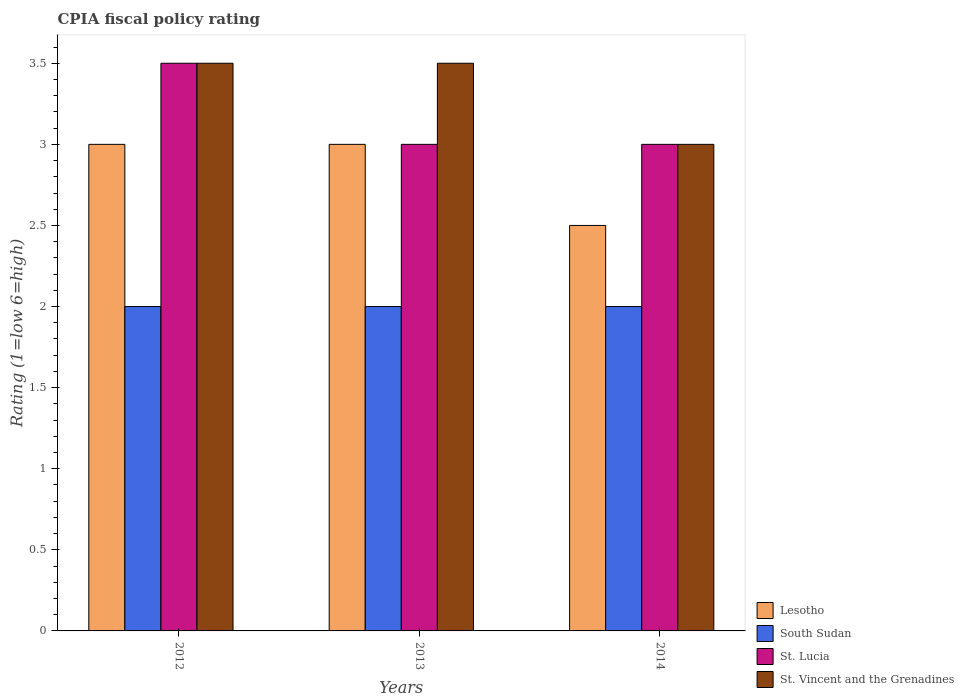Are the number of bars on each tick of the X-axis equal?
Your response must be concise. Yes. How many bars are there on the 2nd tick from the left?
Provide a short and direct response. 4. How many bars are there on the 3rd tick from the right?
Ensure brevity in your answer.  4. What is the label of the 1st group of bars from the left?
Offer a very short reply. 2012. What is the CPIA rating in St. Vincent and the Grenadines in 2013?
Provide a short and direct response. 3.5. Across all years, what is the maximum CPIA rating in South Sudan?
Offer a terse response. 2. In which year was the CPIA rating in Lesotho maximum?
Provide a succinct answer. 2012. In which year was the CPIA rating in St. Lucia minimum?
Provide a short and direct response. 2013. What is the total CPIA rating in Lesotho in the graph?
Give a very brief answer. 8.5. What is the difference between the CPIA rating in St. Lucia in 2013 and that in 2014?
Offer a terse response. 0. What is the average CPIA rating in St. Vincent and the Grenadines per year?
Provide a succinct answer. 3.33. What is the ratio of the CPIA rating in St. Lucia in 2012 to that in 2014?
Your answer should be compact. 1.17. Is the difference between the CPIA rating in St. Vincent and the Grenadines in 2012 and 2013 greater than the difference between the CPIA rating in South Sudan in 2012 and 2013?
Ensure brevity in your answer.  No. What is the difference between the highest and the second highest CPIA rating in St. Lucia?
Provide a short and direct response. 0.5. What is the difference between the highest and the lowest CPIA rating in St. Lucia?
Make the answer very short. 0.5. In how many years, is the CPIA rating in Lesotho greater than the average CPIA rating in Lesotho taken over all years?
Keep it short and to the point. 2. What does the 3rd bar from the left in 2013 represents?
Make the answer very short. St. Lucia. What does the 2nd bar from the right in 2014 represents?
Provide a succinct answer. St. Lucia. Is it the case that in every year, the sum of the CPIA rating in Lesotho and CPIA rating in South Sudan is greater than the CPIA rating in St. Lucia?
Your response must be concise. Yes. How many bars are there?
Ensure brevity in your answer.  12. How many years are there in the graph?
Your answer should be very brief. 3. Does the graph contain grids?
Ensure brevity in your answer.  No. Where does the legend appear in the graph?
Your response must be concise. Bottom right. How many legend labels are there?
Keep it short and to the point. 4. How are the legend labels stacked?
Provide a short and direct response. Vertical. What is the title of the graph?
Offer a terse response. CPIA fiscal policy rating. Does "Heavily indebted poor countries" appear as one of the legend labels in the graph?
Make the answer very short. No. What is the label or title of the X-axis?
Provide a succinct answer. Years. What is the Rating (1=low 6=high) of St. Lucia in 2012?
Ensure brevity in your answer.  3.5. What is the Rating (1=low 6=high) of St. Vincent and the Grenadines in 2012?
Offer a very short reply. 3.5. What is the Rating (1=low 6=high) in Lesotho in 2013?
Provide a succinct answer. 3. What is the Rating (1=low 6=high) of Lesotho in 2014?
Keep it short and to the point. 2.5. What is the Rating (1=low 6=high) of St. Vincent and the Grenadines in 2014?
Ensure brevity in your answer.  3. Across all years, what is the maximum Rating (1=low 6=high) in South Sudan?
Ensure brevity in your answer.  2. Across all years, what is the maximum Rating (1=low 6=high) in St. Lucia?
Provide a short and direct response. 3.5. Across all years, what is the maximum Rating (1=low 6=high) of St. Vincent and the Grenadines?
Your answer should be compact. 3.5. Across all years, what is the minimum Rating (1=low 6=high) of South Sudan?
Your response must be concise. 2. Across all years, what is the minimum Rating (1=low 6=high) in St. Vincent and the Grenadines?
Ensure brevity in your answer.  3. What is the total Rating (1=low 6=high) of South Sudan in the graph?
Offer a terse response. 6. What is the difference between the Rating (1=low 6=high) of Lesotho in 2012 and that in 2013?
Offer a very short reply. 0. What is the difference between the Rating (1=low 6=high) of Lesotho in 2012 and that in 2014?
Your answer should be compact. 0.5. What is the difference between the Rating (1=low 6=high) of South Sudan in 2012 and that in 2014?
Give a very brief answer. 0. What is the difference between the Rating (1=low 6=high) in St. Lucia in 2013 and that in 2014?
Offer a very short reply. 0. What is the difference between the Rating (1=low 6=high) in Lesotho in 2012 and the Rating (1=low 6=high) in South Sudan in 2013?
Keep it short and to the point. 1. What is the difference between the Rating (1=low 6=high) in South Sudan in 2012 and the Rating (1=low 6=high) in St. Vincent and the Grenadines in 2013?
Your response must be concise. -1.5. What is the difference between the Rating (1=low 6=high) in Lesotho in 2012 and the Rating (1=low 6=high) in South Sudan in 2014?
Offer a very short reply. 1. What is the difference between the Rating (1=low 6=high) of Lesotho in 2012 and the Rating (1=low 6=high) of St. Vincent and the Grenadines in 2014?
Your response must be concise. 0. What is the difference between the Rating (1=low 6=high) of South Sudan in 2012 and the Rating (1=low 6=high) of St. Vincent and the Grenadines in 2014?
Offer a very short reply. -1. What is the difference between the Rating (1=low 6=high) of Lesotho in 2013 and the Rating (1=low 6=high) of South Sudan in 2014?
Make the answer very short. 1. What is the difference between the Rating (1=low 6=high) of Lesotho in 2013 and the Rating (1=low 6=high) of St. Lucia in 2014?
Offer a terse response. 0. What is the difference between the Rating (1=low 6=high) in South Sudan in 2013 and the Rating (1=low 6=high) in St. Lucia in 2014?
Give a very brief answer. -1. What is the difference between the Rating (1=low 6=high) in South Sudan in 2013 and the Rating (1=low 6=high) in St. Vincent and the Grenadines in 2014?
Ensure brevity in your answer.  -1. What is the average Rating (1=low 6=high) of Lesotho per year?
Your answer should be compact. 2.83. What is the average Rating (1=low 6=high) of South Sudan per year?
Offer a terse response. 2. What is the average Rating (1=low 6=high) in St. Lucia per year?
Provide a short and direct response. 3.17. In the year 2012, what is the difference between the Rating (1=low 6=high) in South Sudan and Rating (1=low 6=high) in St. Lucia?
Your answer should be very brief. -1.5. In the year 2012, what is the difference between the Rating (1=low 6=high) in South Sudan and Rating (1=low 6=high) in St. Vincent and the Grenadines?
Give a very brief answer. -1.5. In the year 2013, what is the difference between the Rating (1=low 6=high) in Lesotho and Rating (1=low 6=high) in St. Lucia?
Keep it short and to the point. 0. In the year 2013, what is the difference between the Rating (1=low 6=high) in Lesotho and Rating (1=low 6=high) in St. Vincent and the Grenadines?
Make the answer very short. -0.5. In the year 2013, what is the difference between the Rating (1=low 6=high) in South Sudan and Rating (1=low 6=high) in St. Vincent and the Grenadines?
Provide a succinct answer. -1.5. In the year 2014, what is the difference between the Rating (1=low 6=high) of Lesotho and Rating (1=low 6=high) of South Sudan?
Give a very brief answer. 0.5. In the year 2014, what is the difference between the Rating (1=low 6=high) in Lesotho and Rating (1=low 6=high) in St. Lucia?
Ensure brevity in your answer.  -0.5. In the year 2014, what is the difference between the Rating (1=low 6=high) in Lesotho and Rating (1=low 6=high) in St. Vincent and the Grenadines?
Offer a very short reply. -0.5. In the year 2014, what is the difference between the Rating (1=low 6=high) in South Sudan and Rating (1=low 6=high) in St. Vincent and the Grenadines?
Offer a very short reply. -1. What is the ratio of the Rating (1=low 6=high) in Lesotho in 2012 to that in 2013?
Offer a very short reply. 1. What is the ratio of the Rating (1=low 6=high) of St. Lucia in 2012 to that in 2013?
Ensure brevity in your answer.  1.17. What is the ratio of the Rating (1=low 6=high) in Lesotho in 2012 to that in 2014?
Offer a very short reply. 1.2. What is the ratio of the Rating (1=low 6=high) in St. Lucia in 2012 to that in 2014?
Offer a very short reply. 1.17. What is the ratio of the Rating (1=low 6=high) in Lesotho in 2013 to that in 2014?
Provide a short and direct response. 1.2. What is the ratio of the Rating (1=low 6=high) in South Sudan in 2013 to that in 2014?
Your answer should be very brief. 1. What is the ratio of the Rating (1=low 6=high) in St. Vincent and the Grenadines in 2013 to that in 2014?
Your response must be concise. 1.17. What is the difference between the highest and the second highest Rating (1=low 6=high) in Lesotho?
Your answer should be compact. 0. What is the difference between the highest and the lowest Rating (1=low 6=high) of Lesotho?
Provide a short and direct response. 0.5. What is the difference between the highest and the lowest Rating (1=low 6=high) of South Sudan?
Provide a short and direct response. 0. What is the difference between the highest and the lowest Rating (1=low 6=high) of St. Vincent and the Grenadines?
Your answer should be very brief. 0.5. 